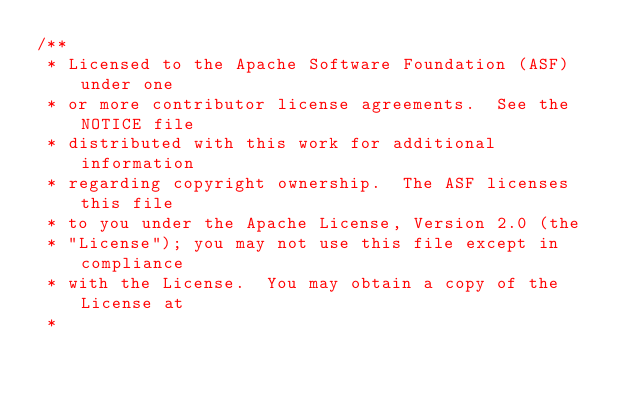<code> <loc_0><loc_0><loc_500><loc_500><_C_>/**
 * Licensed to the Apache Software Foundation (ASF) under one
 * or more contributor license agreements.  See the NOTICE file
 * distributed with this work for additional information
 * regarding copyright ownership.  The ASF licenses this file
 * to you under the Apache License, Version 2.0 (the
 * "License"); you may not use this file except in compliance
 * with the License.  You may obtain a copy of the License at
 *</code> 